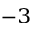<formula> <loc_0><loc_0><loc_500><loc_500>^ { - 3 }</formula> 